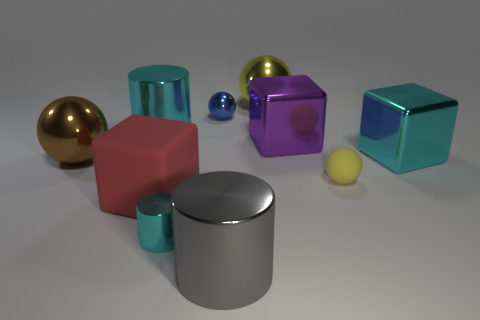Subtract all brown spheres. How many spheres are left? 3 Subtract all spheres. How many objects are left? 6 Subtract 3 blocks. How many blocks are left? 0 Subtract all cyan balls. Subtract all green cylinders. How many balls are left? 4 Subtract all purple cylinders. How many yellow balls are left? 2 Subtract all big red shiny cubes. Subtract all big metal blocks. How many objects are left? 8 Add 1 big matte things. How many big matte things are left? 2 Add 7 purple metallic things. How many purple metallic things exist? 8 Subtract all blue spheres. How many spheres are left? 3 Subtract 1 blue spheres. How many objects are left? 9 